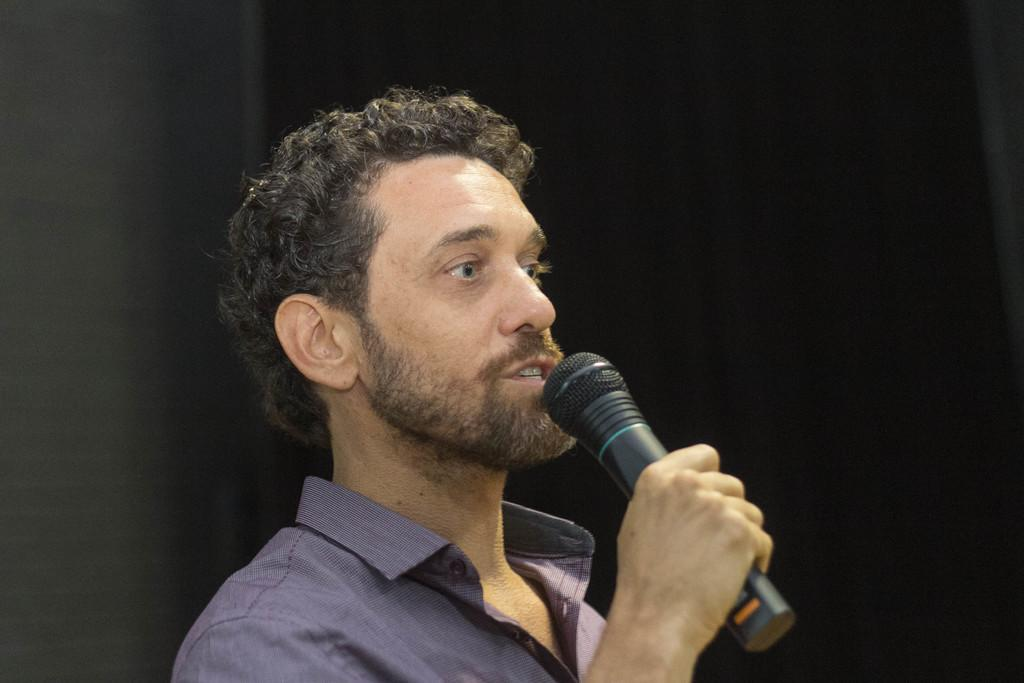What is the main subject of the image? There is a person in the image. What is the person wearing? The person is wearing a shirt. What is the person holding in their hand? The person is holding a microphone with one hand. What is the person doing in the image? The person is speaking. What can be observed about the background of the image? The background of the image is dark in color. Can you see any monkeys playing with a flame in the image? There are no monkeys or flames present in the image. Are there any bears visible in the background of the image? There are no bears present in the image; the background is dark in color. 